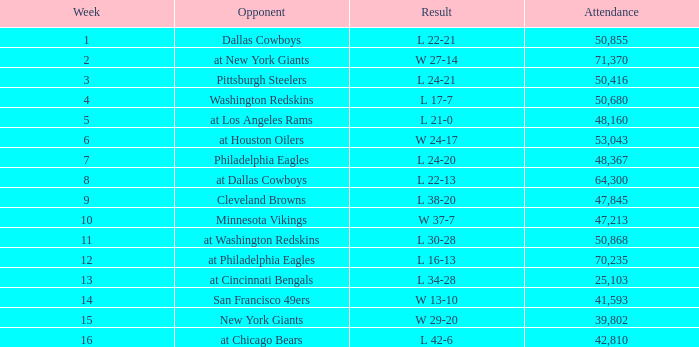What is the highest week when attendance is greater than 64,300 with a result of w 27-14? 2.0. 